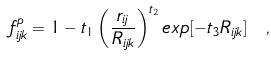<formula> <loc_0><loc_0><loc_500><loc_500>f ^ { p } _ { i j k } = 1 - t _ { 1 } \left ( \frac { r _ { i j } } { R _ { i j k } } \right ) ^ { t _ { 2 } } e x p [ - t _ { 3 } R _ { i j k } ] \ ,</formula> 